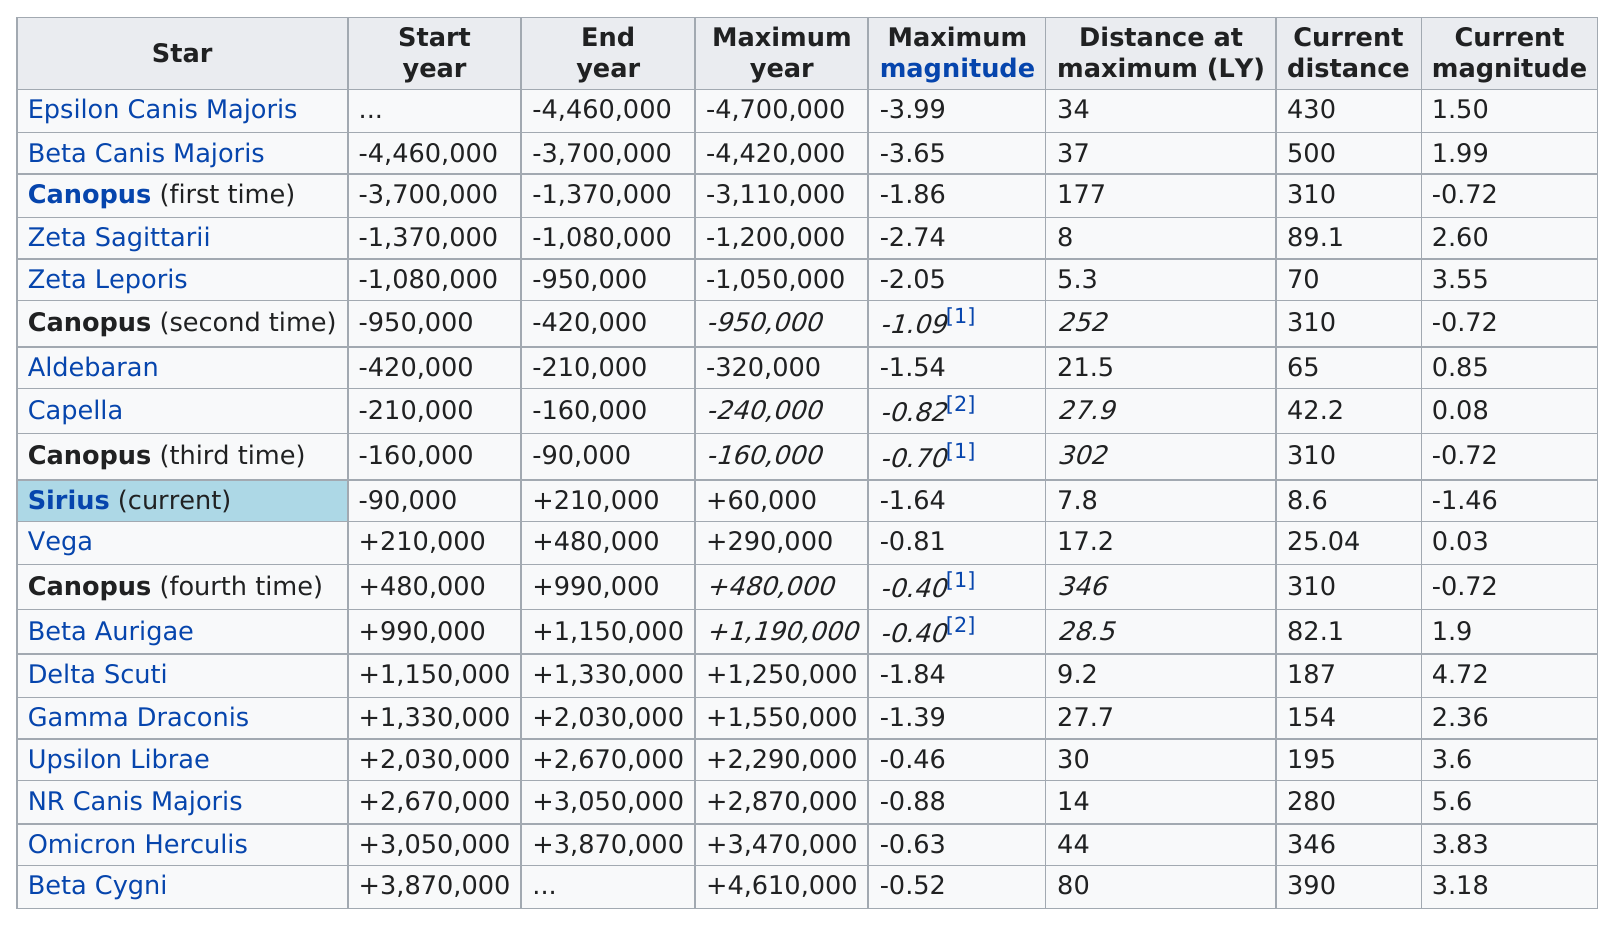Point out several critical features in this image. Beta Cygni is the only star with a distance at maximum of 80. The nearest current distance is 491.4 meters, while the farthest current distance is also 491.4 meters. There are five stars that have a maximum magnitude less than zero. The distance between Epsilon Canis Majoris and Zeta Sagittarii is approximately 26 light-years. Canopus has the highest distance at maximum among all stars. 